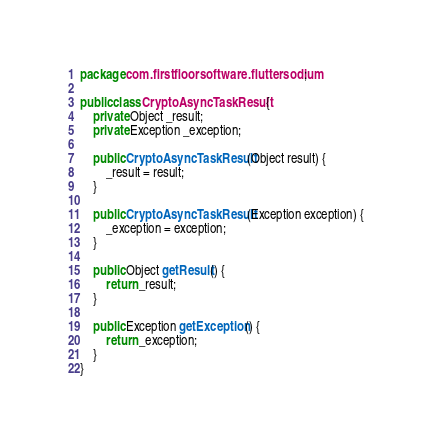Convert code to text. <code><loc_0><loc_0><loc_500><loc_500><_Java_>package com.firstfloorsoftware.fluttersodium;

public class CryptoAsyncTaskResult {
    private Object _result;
    private Exception _exception;

    public CryptoAsyncTaskResult(Object result) {
        _result = result;
    }

    public CryptoAsyncTaskResult(Exception exception) {
        _exception = exception;
    }

    public Object getResult() {
        return _result;
    }

    public Exception getException() {
        return _exception;
    }
}</code> 